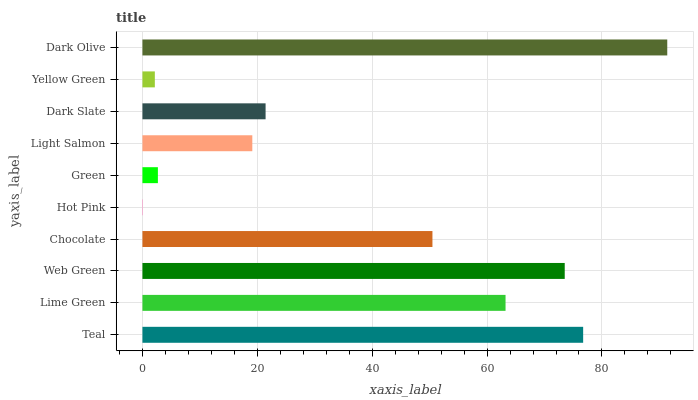Is Hot Pink the minimum?
Answer yes or no. Yes. Is Dark Olive the maximum?
Answer yes or no. Yes. Is Lime Green the minimum?
Answer yes or no. No. Is Lime Green the maximum?
Answer yes or no. No. Is Teal greater than Lime Green?
Answer yes or no. Yes. Is Lime Green less than Teal?
Answer yes or no. Yes. Is Lime Green greater than Teal?
Answer yes or no. No. Is Teal less than Lime Green?
Answer yes or no. No. Is Chocolate the high median?
Answer yes or no. Yes. Is Dark Slate the low median?
Answer yes or no. Yes. Is Hot Pink the high median?
Answer yes or no. No. Is Yellow Green the low median?
Answer yes or no. No. 